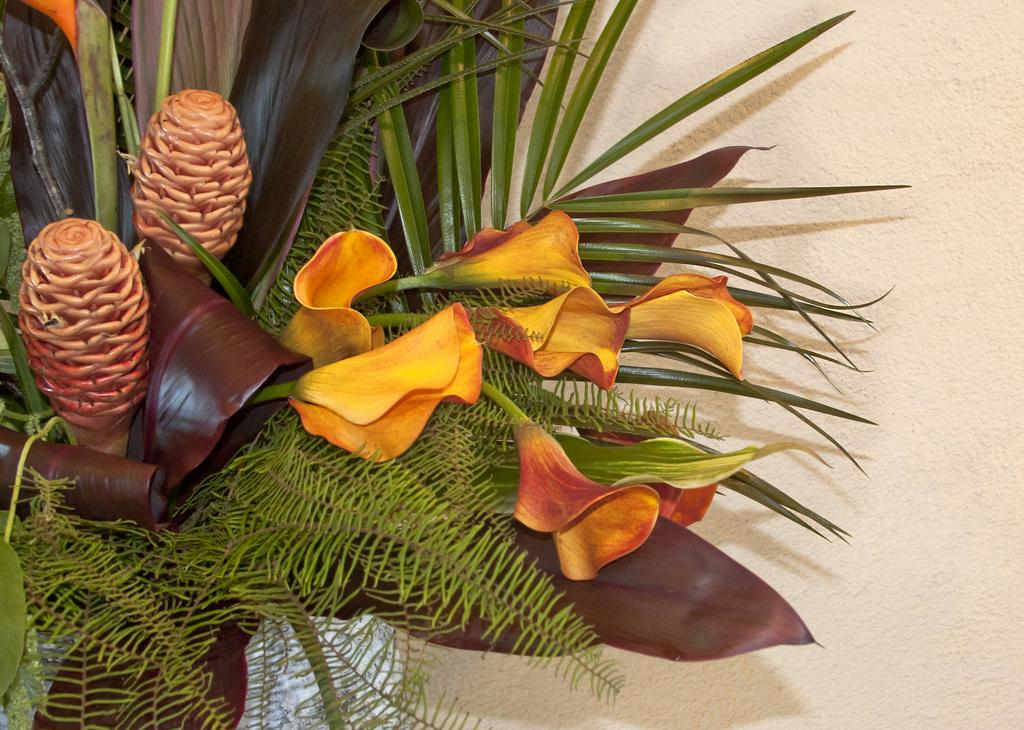What is the main subject of the picture? The main subject of the picture is a bouquet. What types of elements are included in the bouquet? The bouquet contains flowers, plants, and leaves. Where is the bouquet located in relation to other objects in the image? The bouquet is near a wall. Can you hear the sound of the eggnog being poured in the image? There is no eggnog present in the image, and therefore no sound of it being poured can be heard. 